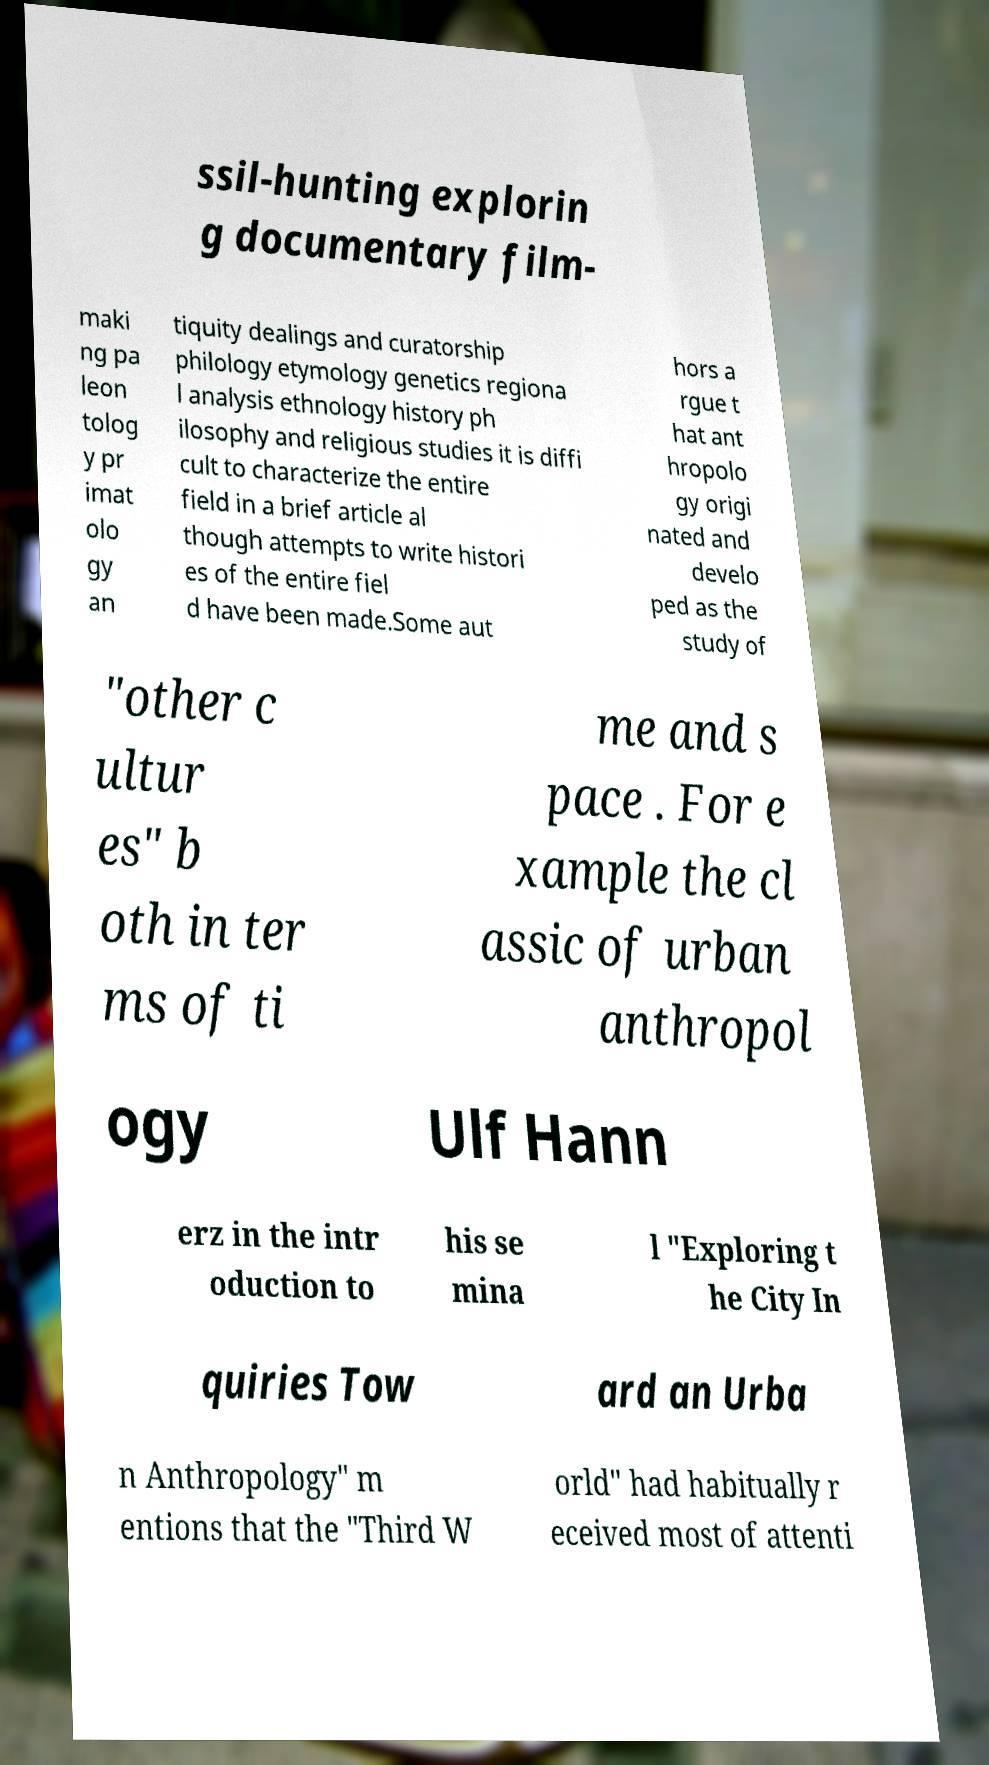I need the written content from this picture converted into text. Can you do that? ssil-hunting explorin g documentary film- maki ng pa leon tolog y pr imat olo gy an tiquity dealings and curatorship philology etymology genetics regiona l analysis ethnology history ph ilosophy and religious studies it is diffi cult to characterize the entire field in a brief article al though attempts to write histori es of the entire fiel d have been made.Some aut hors a rgue t hat ant hropolo gy origi nated and develo ped as the study of "other c ultur es" b oth in ter ms of ti me and s pace . For e xample the cl assic of urban anthropol ogy Ulf Hann erz in the intr oduction to his se mina l "Exploring t he City In quiries Tow ard an Urba n Anthropology" m entions that the "Third W orld" had habitually r eceived most of attenti 